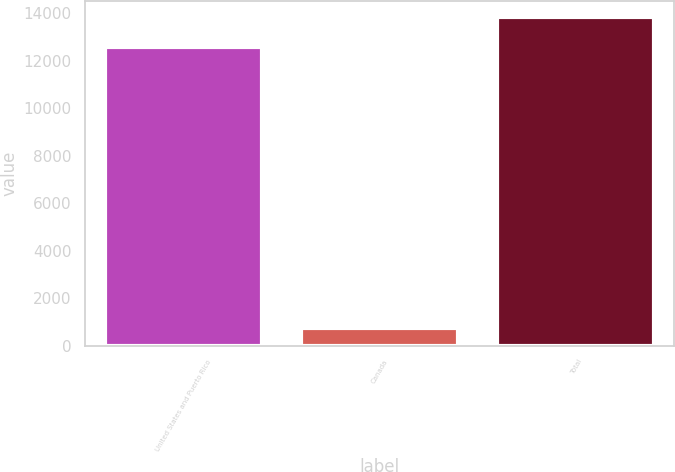<chart> <loc_0><loc_0><loc_500><loc_500><bar_chart><fcel>United States and Puerto Rico<fcel>Canada<fcel>Total<nl><fcel>12566<fcel>744<fcel>13822.6<nl></chart> 